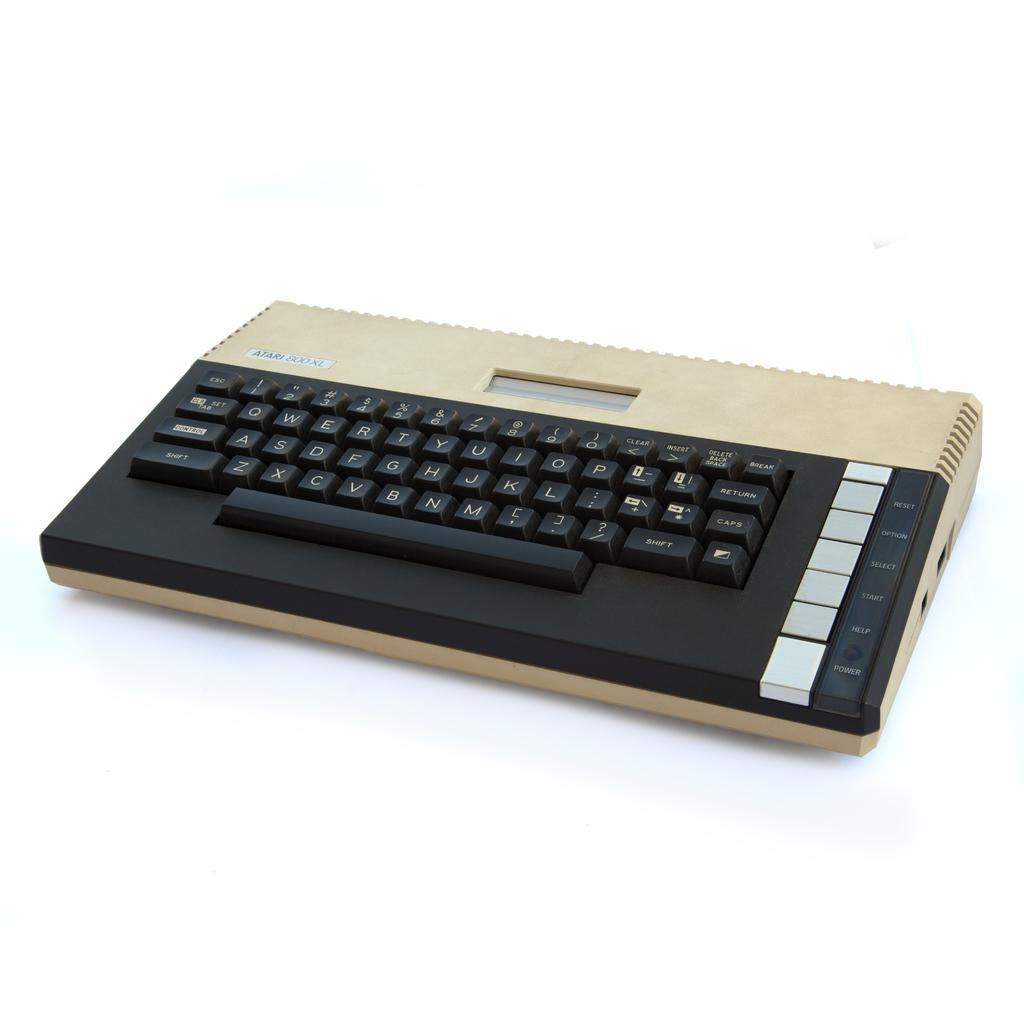Provide a one-sentence caption for the provided image. The Atari 800 XL console is tan and black. 